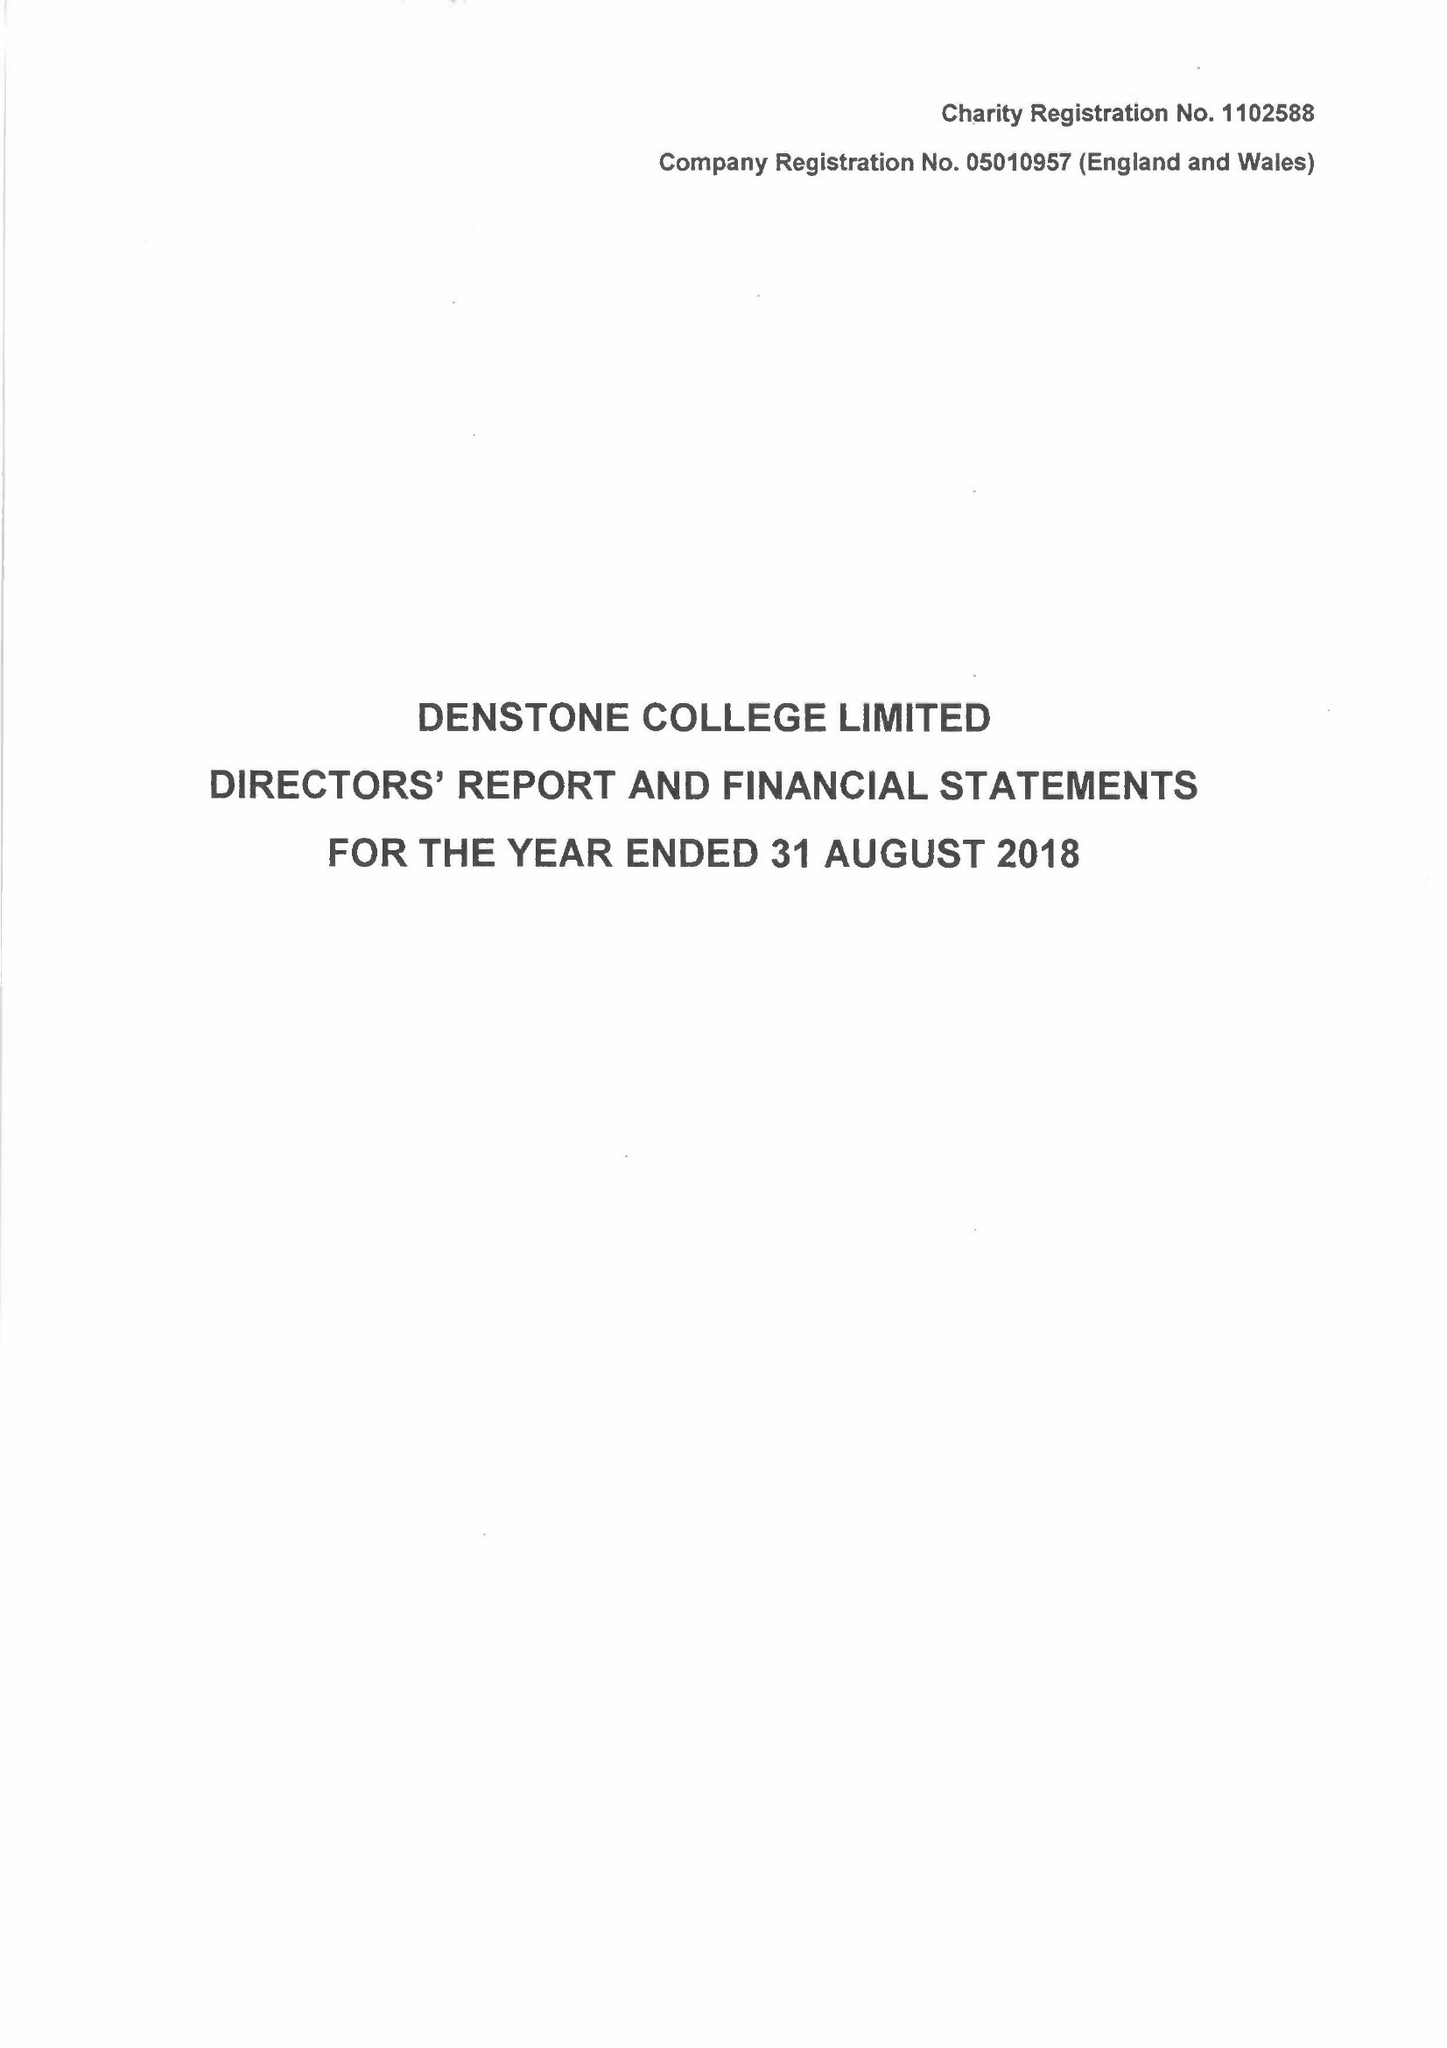What is the value for the report_date?
Answer the question using a single word or phrase. 2018-08-31 